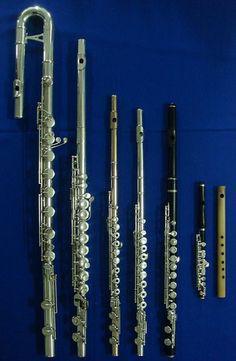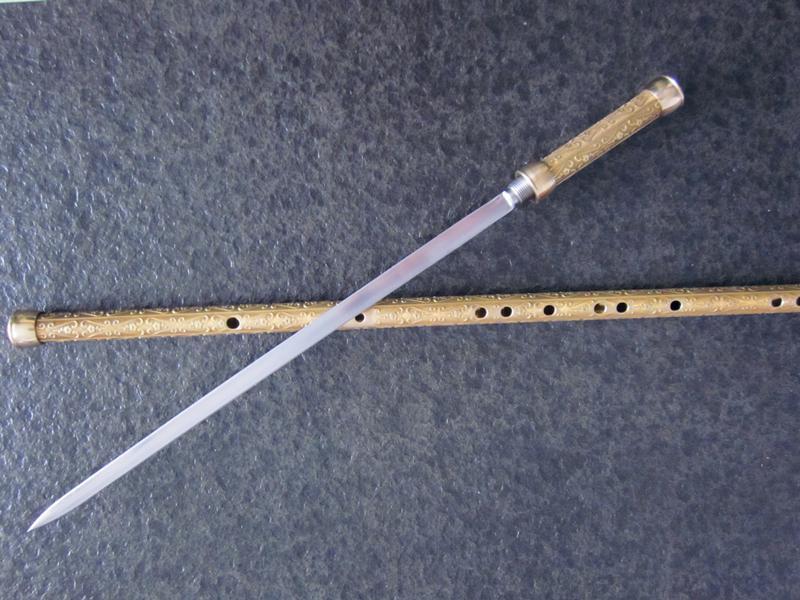The first image is the image on the left, the second image is the image on the right. For the images displayed, is the sentence "One image shows three flutes side by side, with their ends closer together at the top of the image." factually correct? Answer yes or no. No. The first image is the image on the left, the second image is the image on the right. Analyze the images presented: Is the assertion "One of the images contains exactly three flutes." valid? Answer yes or no. No. 